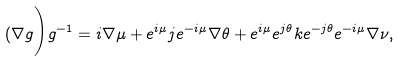<formula> <loc_0><loc_0><loc_500><loc_500>( \nabla g \Big ) g ^ { - 1 } = i \nabla \mu + e ^ { i \mu } j e ^ { - i \mu } \nabla \theta + e ^ { i \mu } e ^ { j \theta } k e ^ { - j \theta } e ^ { - i \mu } \nabla \nu , \\</formula> 